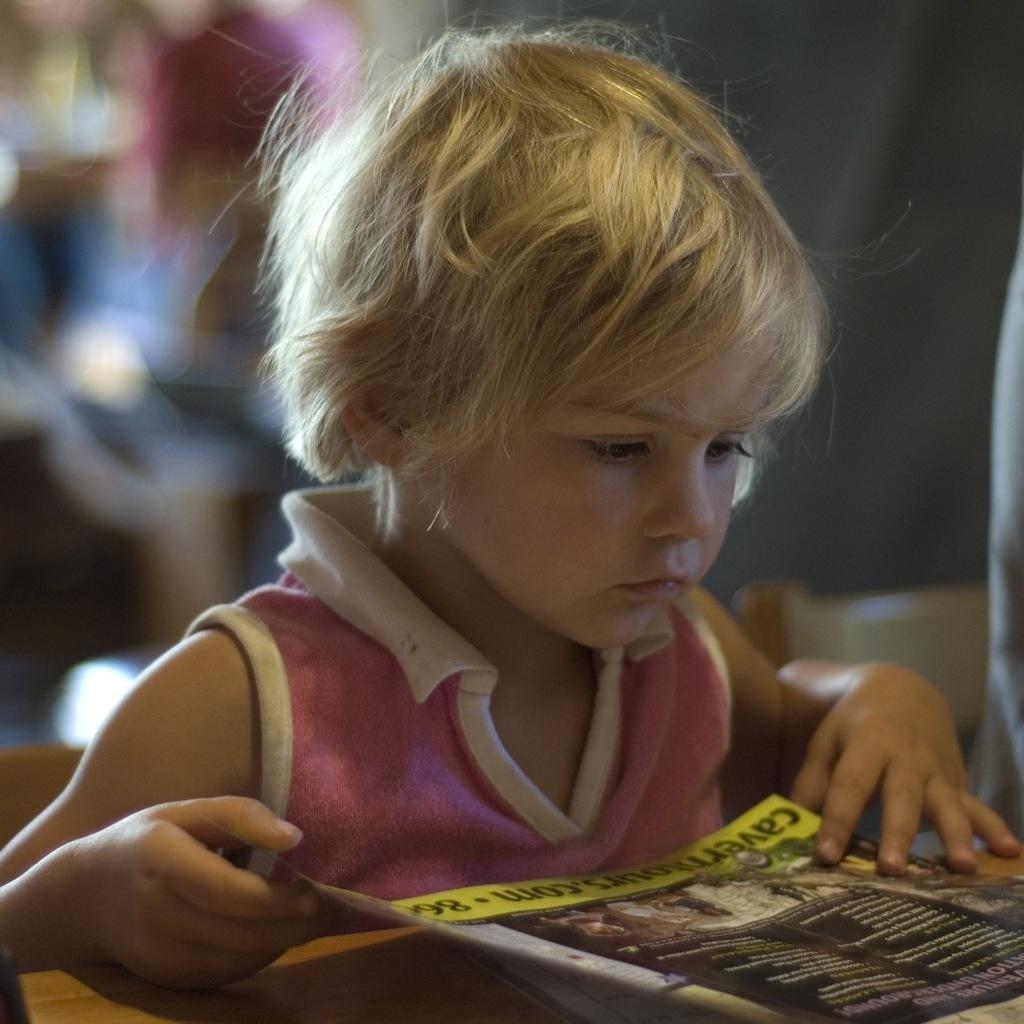In one or two sentences, can you explain what this image depicts? This image is taken indoors. In this image the background is a little blurred. In the middle of the image a kid is sitting on the chair and he is holding a book in his hands. At the bottom of the image there is a table. 